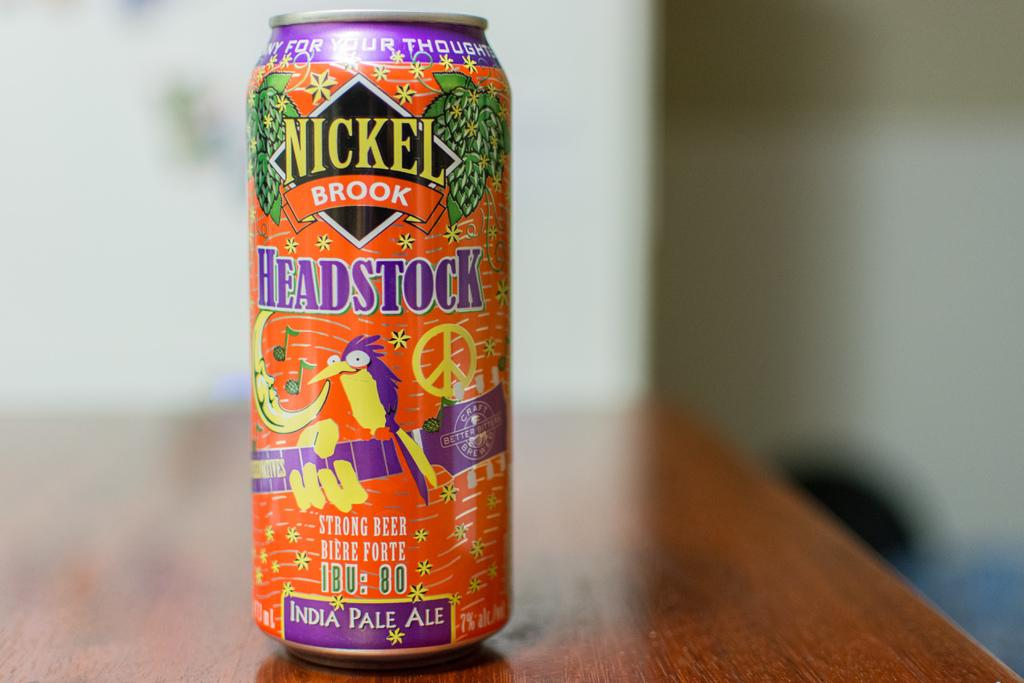Provide a one-sentence caption for the provided image. A bottle of Headstock pale ale has a bright orange can with purple and yellow designs. 